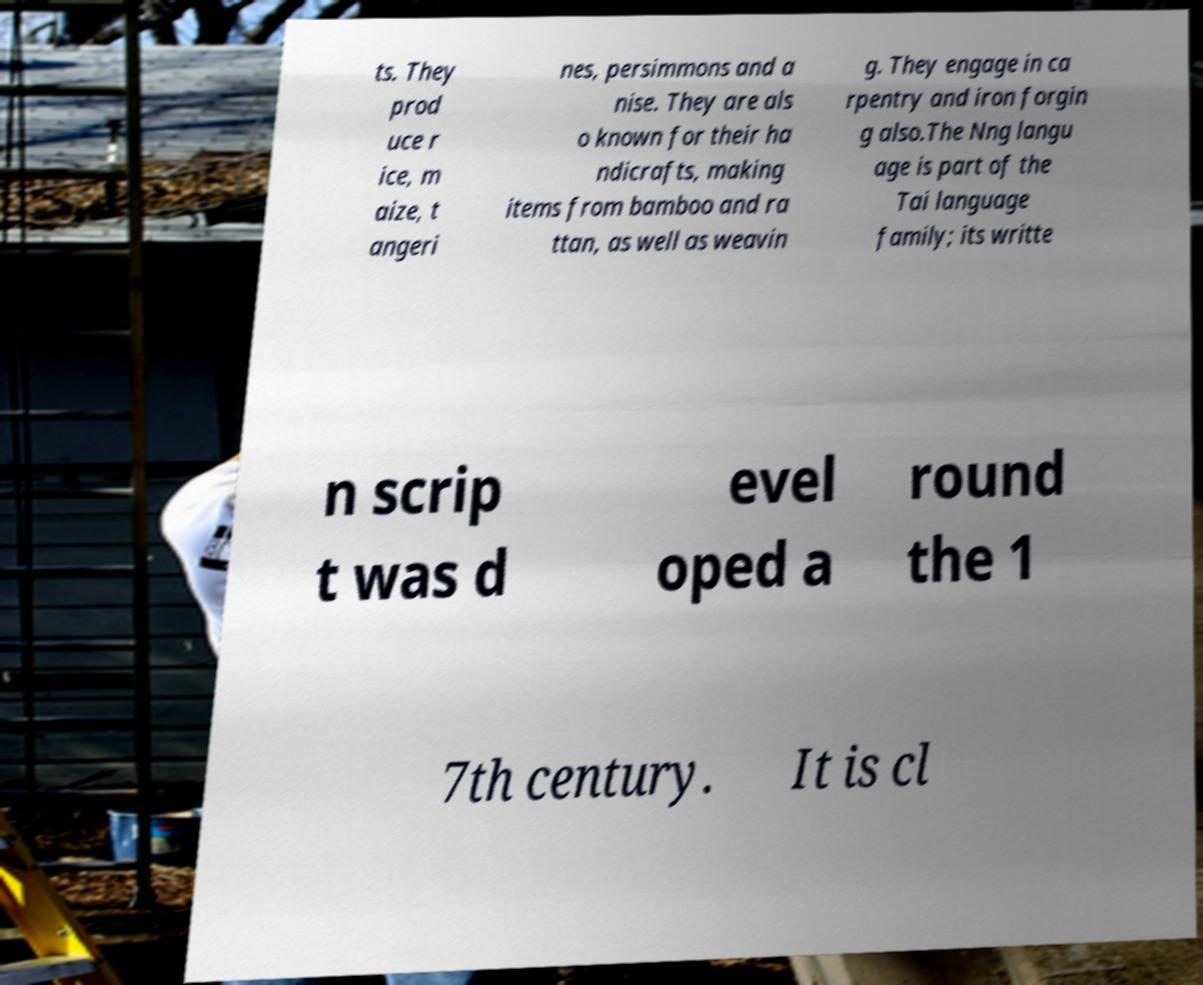Please read and relay the text visible in this image. What does it say? ts. They prod uce r ice, m aize, t angeri nes, persimmons and a nise. They are als o known for their ha ndicrafts, making items from bamboo and ra ttan, as well as weavin g. They engage in ca rpentry and iron forgin g also.The Nng langu age is part of the Tai language family; its writte n scrip t was d evel oped a round the 1 7th century. It is cl 